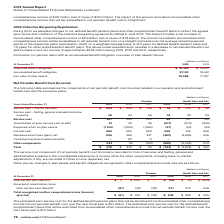According to Verizon Communications's financial document, What was the net increase to accumulated other comprehensive income in 2016? According to the financial document, $2.9 billion. The relevant text states: "rease to Accumulated other comprehensive income of $2.9 billion (net of taxes of $1.8 billion). The amount recorded in Accumulated other comprehensive income will b..." Also, What is the duration of postretirement benefit plan over which the amount will be reclassified? According to the financial document, 7.8 years. The relevant text states: "12.2 years for defined benefit pension plans and 7.8 years for other postretirement benefit plans. The above-noted reclassification resulted in a decrease to..." Also, What was the projected benefit obligation in 2019? According to the financial document, $ 21,190 (in millions). The relevant text states: "Projected benefit obligation $ 21,190 $ 19,510..." Also, can you calculate: What is the change in the projected benefit obligation from 2018 to 2019? Based on the calculation: 21,190 - 19,510, the result is 1680 (in millions). This is based on the information: "Projected benefit obligation $ 21,190 $ 19,510 Projected benefit obligation $ 21,190 $ 19,510..." The key data points involved are: 19,510, 21,190. Also, can you calculate: What was the average accumulated benefit obligation for 2018 and 2019? To answer this question, I need to perform calculations using the financial data. The calculation is: (21,134 + 19,461) / 2, which equals 20297.5 (in millions). This is based on the information: "Accumulated benefit obligation 21,134 19,461 Accumulated benefit obligation 21,134 19,461..." The key data points involved are: 19,461, 21,134. Also, can you calculate: What was the percentage change in the fair value of plan assets from 2018 to 2019? To answer this question, I need to perform calculations using the financial data. The calculation is: 19,388 / 17,757 - 1, which equals 9.19 (percentage). This is based on the information: "Fair value of plan assets 19,388 17,757 Fair value of plan assets 19,388 17,757..." The key data points involved are: 17,757, 19,388. 